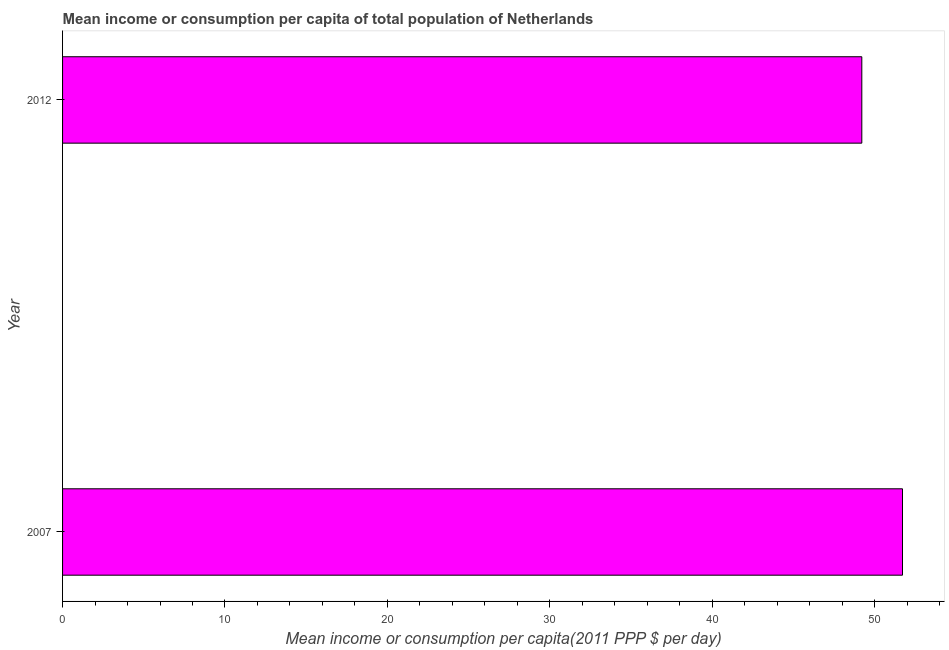Does the graph contain grids?
Your answer should be compact. No. What is the title of the graph?
Make the answer very short. Mean income or consumption per capita of total population of Netherlands. What is the label or title of the X-axis?
Make the answer very short. Mean income or consumption per capita(2011 PPP $ per day). What is the label or title of the Y-axis?
Give a very brief answer. Year. What is the mean income or consumption in 2012?
Give a very brief answer. 49.21. Across all years, what is the maximum mean income or consumption?
Your answer should be compact. 51.72. Across all years, what is the minimum mean income or consumption?
Offer a very short reply. 49.21. In which year was the mean income or consumption maximum?
Offer a terse response. 2007. What is the sum of the mean income or consumption?
Give a very brief answer. 100.93. What is the difference between the mean income or consumption in 2007 and 2012?
Make the answer very short. 2.5. What is the average mean income or consumption per year?
Provide a succinct answer. 50.47. What is the median mean income or consumption?
Offer a very short reply. 50.47. In how many years, is the mean income or consumption greater than 26 $?
Your answer should be compact. 2. Do a majority of the years between 2007 and 2012 (inclusive) have mean income or consumption greater than 22 $?
Your response must be concise. Yes. What is the ratio of the mean income or consumption in 2007 to that in 2012?
Offer a terse response. 1.05. Is the mean income or consumption in 2007 less than that in 2012?
Your answer should be compact. No. How many bars are there?
Provide a succinct answer. 2. Are all the bars in the graph horizontal?
Give a very brief answer. Yes. How many years are there in the graph?
Offer a very short reply. 2. What is the Mean income or consumption per capita(2011 PPP $ per day) of 2007?
Your response must be concise. 51.72. What is the Mean income or consumption per capita(2011 PPP $ per day) in 2012?
Ensure brevity in your answer.  49.21. What is the difference between the Mean income or consumption per capita(2011 PPP $ per day) in 2007 and 2012?
Give a very brief answer. 2.51. What is the ratio of the Mean income or consumption per capita(2011 PPP $ per day) in 2007 to that in 2012?
Your answer should be very brief. 1.05. 